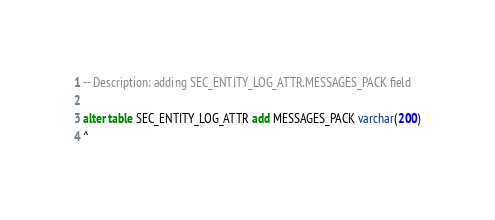Convert code to text. <code><loc_0><loc_0><loc_500><loc_500><_SQL_>-- Description: adding SEC_ENTITY_LOG_ATTR.MESSAGES_PACK field

alter table SEC_ENTITY_LOG_ATTR add MESSAGES_PACK varchar(200)
^
</code> 